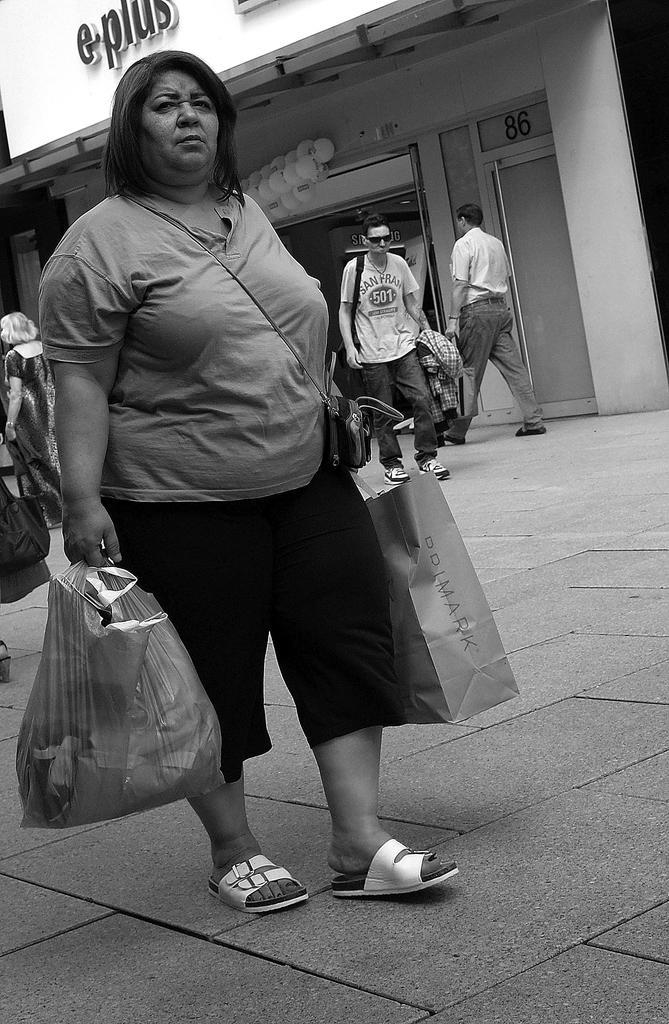Describe this image in one or two sentences. In this black and white image there is a lady walking on the road and holding a bag and a cover in her both hands, behind her there are few people walking on the road. In the background there is a building. 